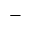Convert formula to latex. <formula><loc_0><loc_0><loc_500><loc_500>^ { - }</formula> 